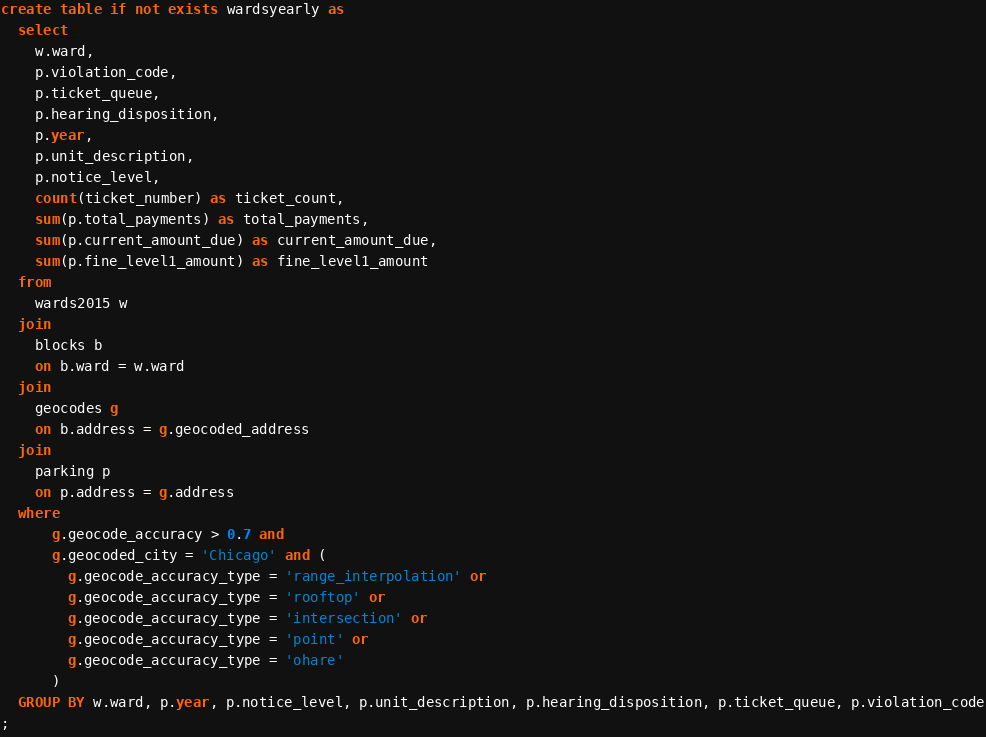Convert code to text. <code><loc_0><loc_0><loc_500><loc_500><_SQL_>create table if not exists wardsyearly as
  select
    w.ward,
    p.violation_code,
    p.ticket_queue,
    p.hearing_disposition,
    p.year,
    p.unit_description,
    p.notice_level,
    count(ticket_number) as ticket_count,
    sum(p.total_payments) as total_payments,
    sum(p.current_amount_due) as current_amount_due,
    sum(p.fine_level1_amount) as fine_level1_amount
  from
    wards2015 w
  join
    blocks b
    on b.ward = w.ward
  join
    geocodes g
    on b.address = g.geocoded_address
  join
    parking p
    on p.address = g.address
  where
      g.geocode_accuracy > 0.7 and
      g.geocoded_city = 'Chicago' and (
        g.geocode_accuracy_type = 'range_interpolation' or
        g.geocode_accuracy_type = 'rooftop' or
        g.geocode_accuracy_type = 'intersection' or
        g.geocode_accuracy_type = 'point' or
        g.geocode_accuracy_type = 'ohare'
      )
  GROUP BY w.ward, p.year, p.notice_level, p.unit_description, p.hearing_disposition, p.ticket_queue, p.violation_code
;
</code> 